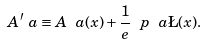<formula> <loc_0><loc_0><loc_500><loc_500>A ^ { \prime } _ { \ } a \equiv A _ { \ } a ( x ) + \frac { 1 } { e } \ p _ { \ } a \L ( x ) .</formula> 